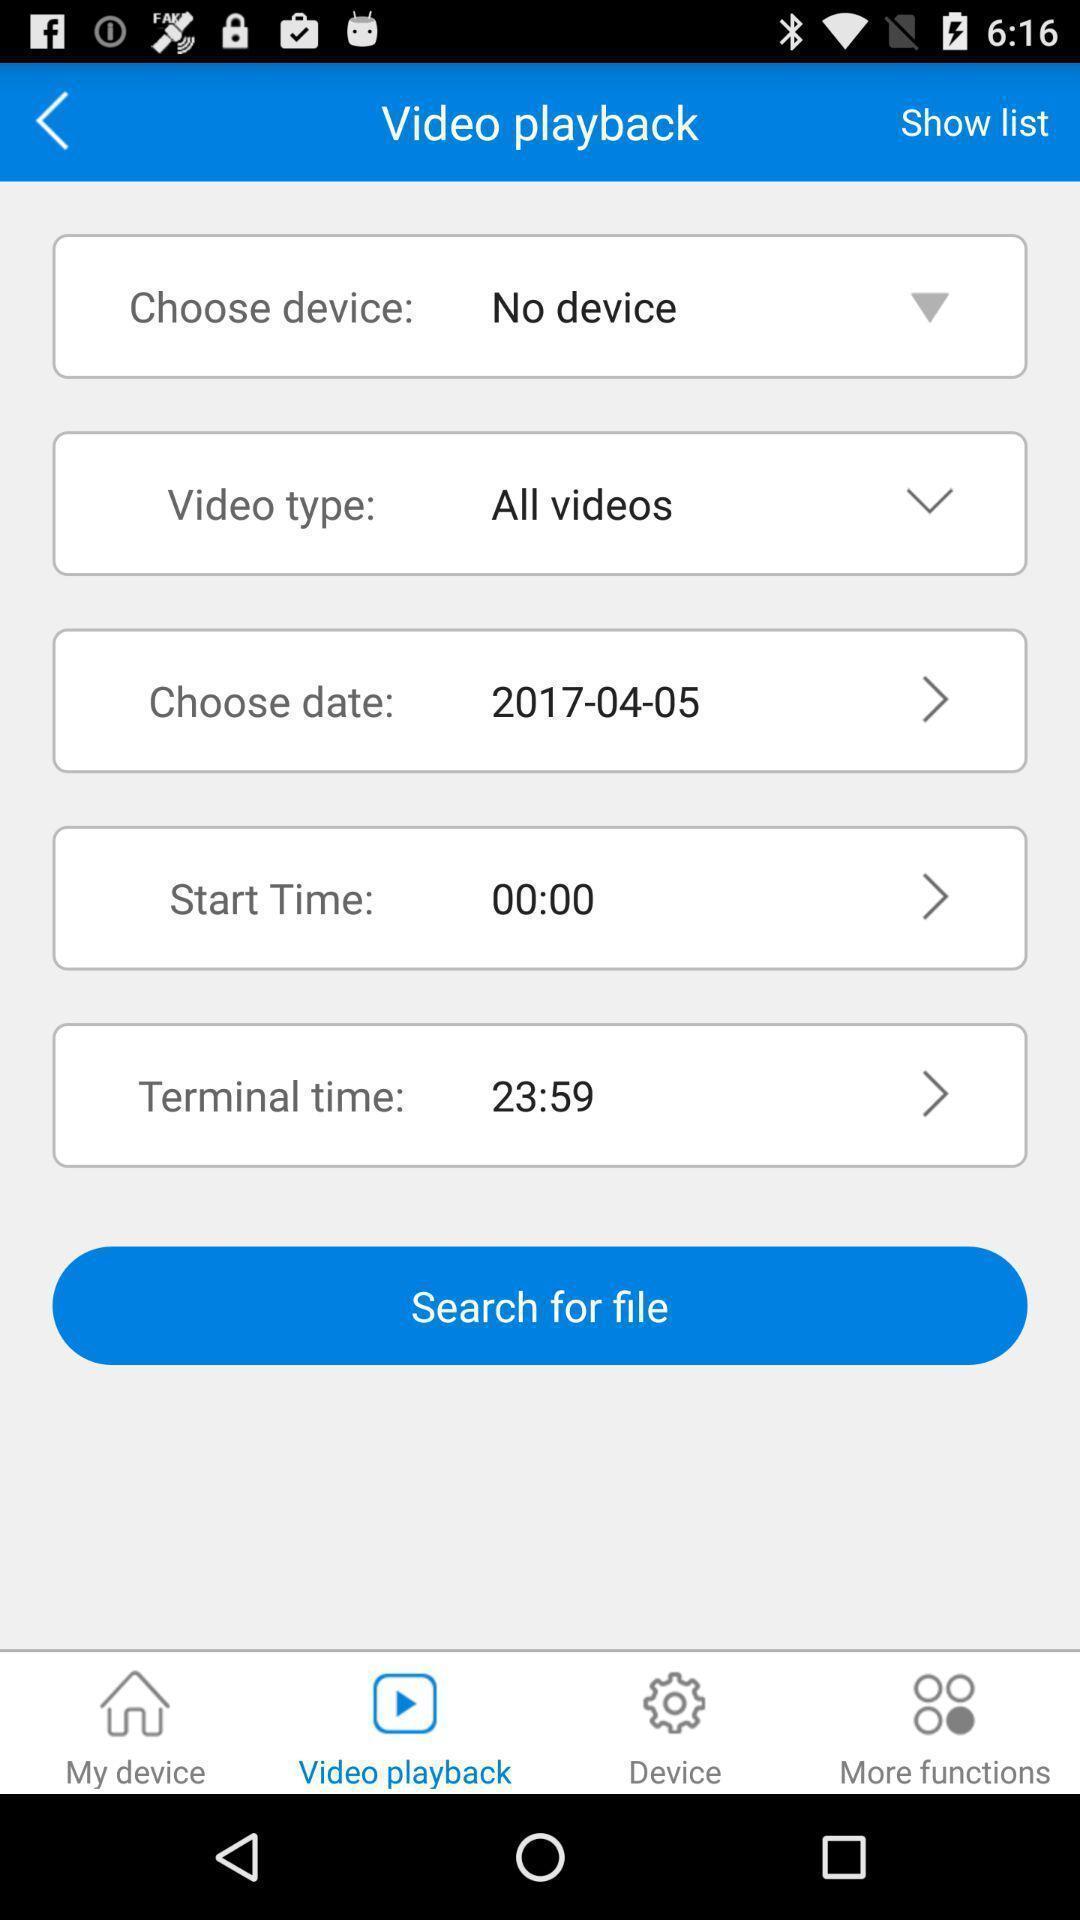What can you discern from this picture? Screen displaying the video playback page with details. 